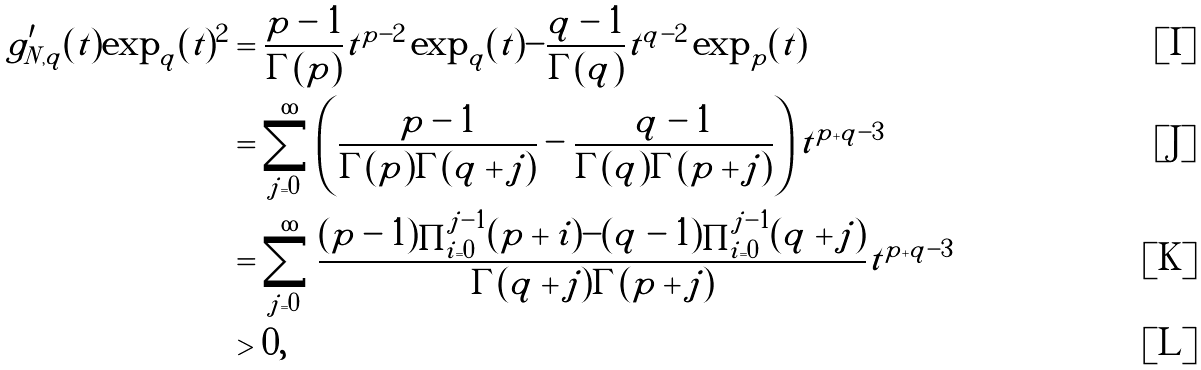Convert formula to latex. <formula><loc_0><loc_0><loc_500><loc_500>g ^ { \prime } _ { N , q } ( t ) \exp _ { q } ( t ) ^ { 2 } & = \frac { p - 1 } { \Gamma ( p ) } t ^ { p - 2 } \exp _ { q } ( t ) - \frac { q - 1 } { \Gamma ( q ) } t ^ { q - 2 } \exp _ { p } ( t ) \\ & = \sum _ { j = 0 } ^ { \infty } \left ( \frac { p - 1 } { \Gamma ( p ) \Gamma ( q + j ) } - \frac { q - 1 } { \Gamma ( q ) \Gamma ( p + j ) } \right ) t ^ { p + q - 3 } \\ & = \sum _ { j = 0 } ^ { \infty } \frac { ( p - 1 ) \prod _ { i = 0 } ^ { j - 1 } ( p + i ) - ( q - 1 ) \prod _ { i = 0 } ^ { j - 1 } ( q + j ) } { \Gamma ( q + j ) \Gamma ( p + j ) } t ^ { p + q - 3 } \\ & > 0 ,</formula> 